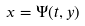Convert formula to latex. <formula><loc_0><loc_0><loc_500><loc_500>x = \Psi ( t , y )</formula> 